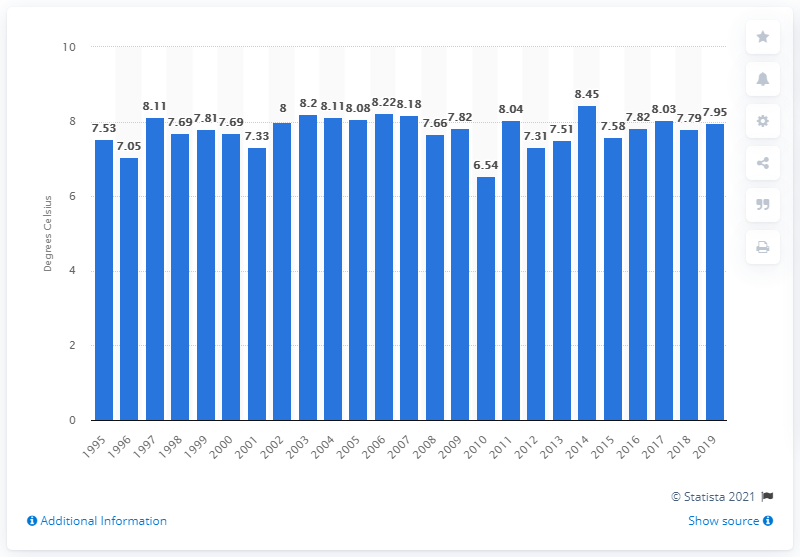Outline some significant characteristics in this image. In 2014, Scotland experienced its warmest year on record. In 2010, Scotland experienced its coldest year on record. 